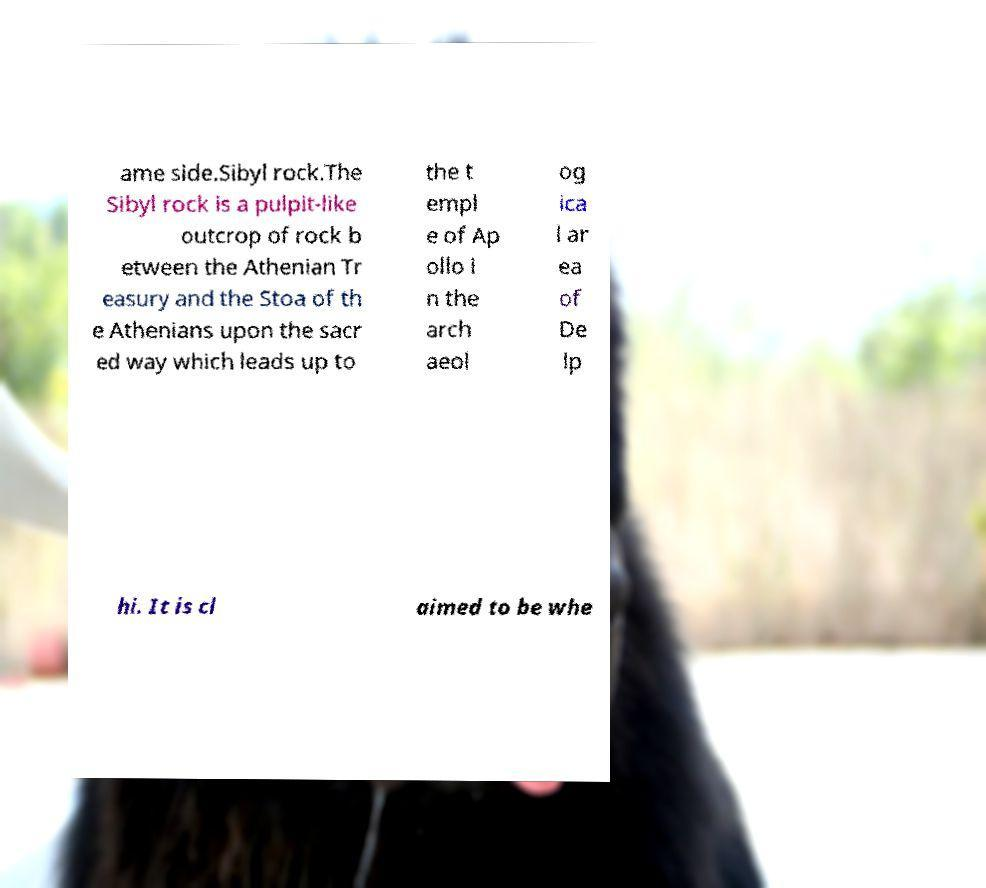Please read and relay the text visible in this image. What does it say? ame side.Sibyl rock.The Sibyl rock is a pulpit-like outcrop of rock b etween the Athenian Tr easury and the Stoa of th e Athenians upon the sacr ed way which leads up to the t empl e of Ap ollo i n the arch aeol og ica l ar ea of De lp hi. It is cl aimed to be whe 